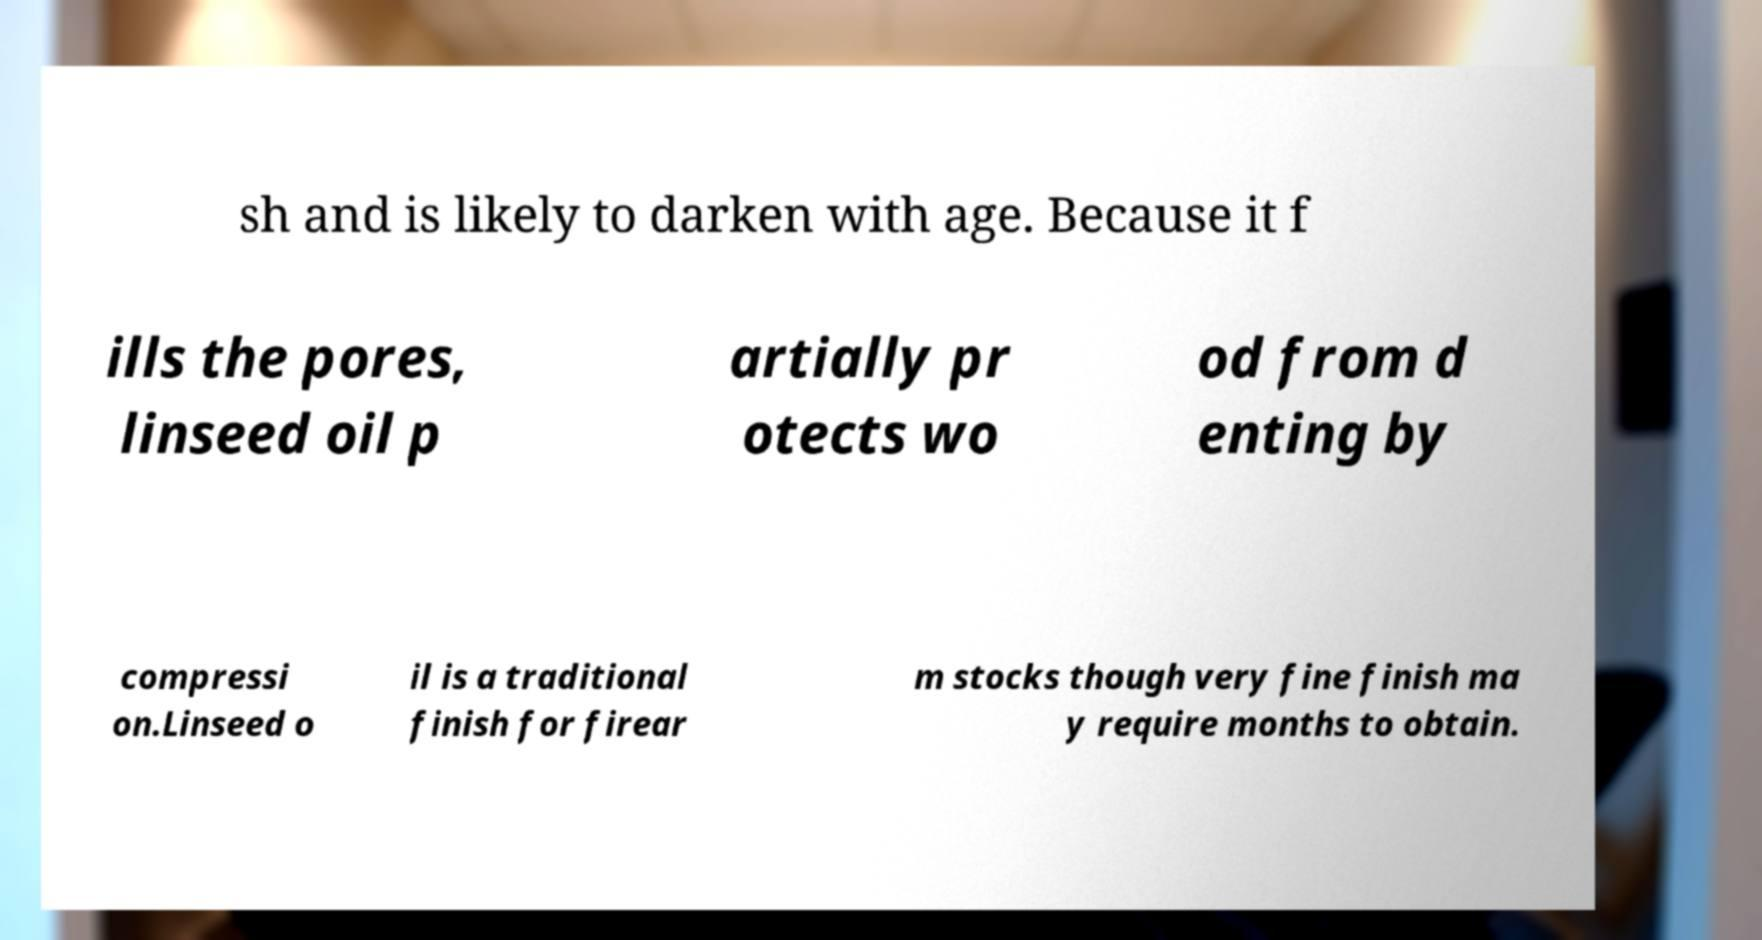Can you read and provide the text displayed in the image?This photo seems to have some interesting text. Can you extract and type it out for me? sh and is likely to darken with age. Because it f ills the pores, linseed oil p artially pr otects wo od from d enting by compressi on.Linseed o il is a traditional finish for firear m stocks though very fine finish ma y require months to obtain. 